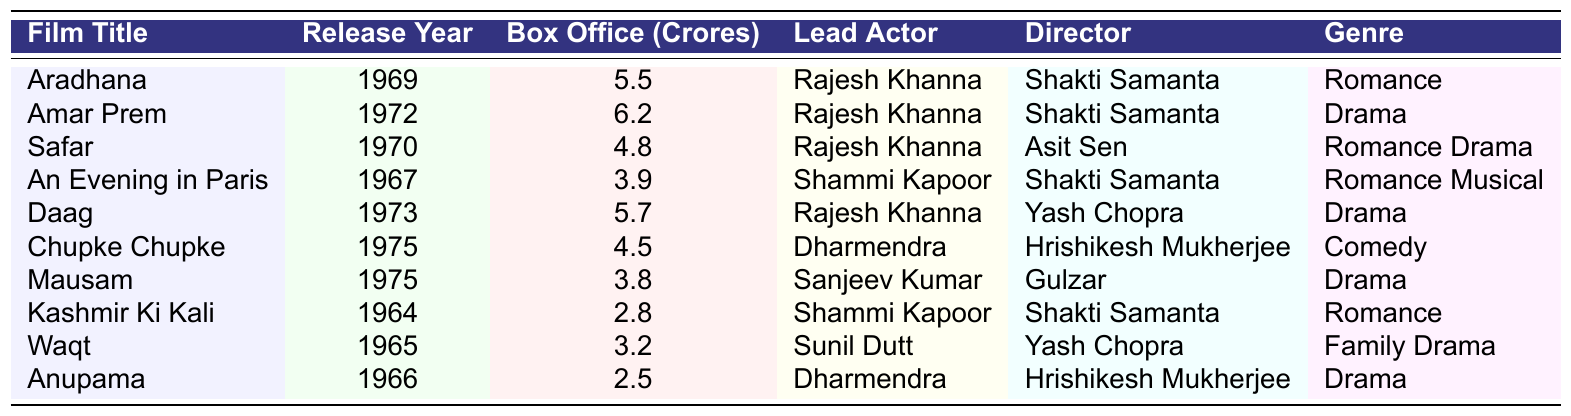What is the highest box office collection among Sharmila Tagore's films? The highest box office collection in the table is 6.2 Crores for the film "Amar Prem" which was released in 1972.
Answer: 6.2 Crores Who directed the film "Kashmir Ki Kali"? The table shows that "Kashmir Ki Kali" was directed by Shakti Samanta.
Answer: Shakti Samanta How many films in the list were released in the 1970s? The films released in the 1970s are "Amar Prem" (1972), "Safar" (1970), "Daag" (1973), "Chupke Chupke" (1975), and "Mausam" (1975) which totals 5 films.
Answer: 5 films Is "An Evening in Paris" a drama? The genre listed for "An Evening in Paris" is "Romance Musical" which means it is not classified as a drama.
Answer: No Which lead actor appears most frequently in the list of films? By counting the occurrences, Rajesh Khanna appears in 5 films.
Answer: Rajesh Khanna What is the average box office collection of the films directed by Shakti Samanta? The films directed by Shakti Samanta are "Aradhana" (5.5), "Amar Prem" (6.2), "Safar" (4.8), and "An Evening in Paris" (3.9). Summing these gives 20.4, and dividing by 4 yields an average of 5.1.
Answer: 5.1 Crores Which film has the lowest box office collection? According to the table, "Anupama" has the lowest box office collection of 2.5 Crores.
Answer: 2.5 Crores What genre is the film "Chupke Chupke"? The table identifies "Chupke Chupke" as a "Comedy" genre.
Answer: Comedy If we sum the box office collections of all films, what is the total? The total box office collection is calculated by adding all box office collections: (5.5 + 6.2 + 4.8 + 3.9 + 5.7 + 4.5 + 3.8 + 2.8 + 3.2 + 2.5) = 38.8 Crores.
Answer: 38.8 Crores Which year saw the release of the film "Daag"? The film "Daag" was released in the year 1973 as per the data in the table.
Answer: 1973 